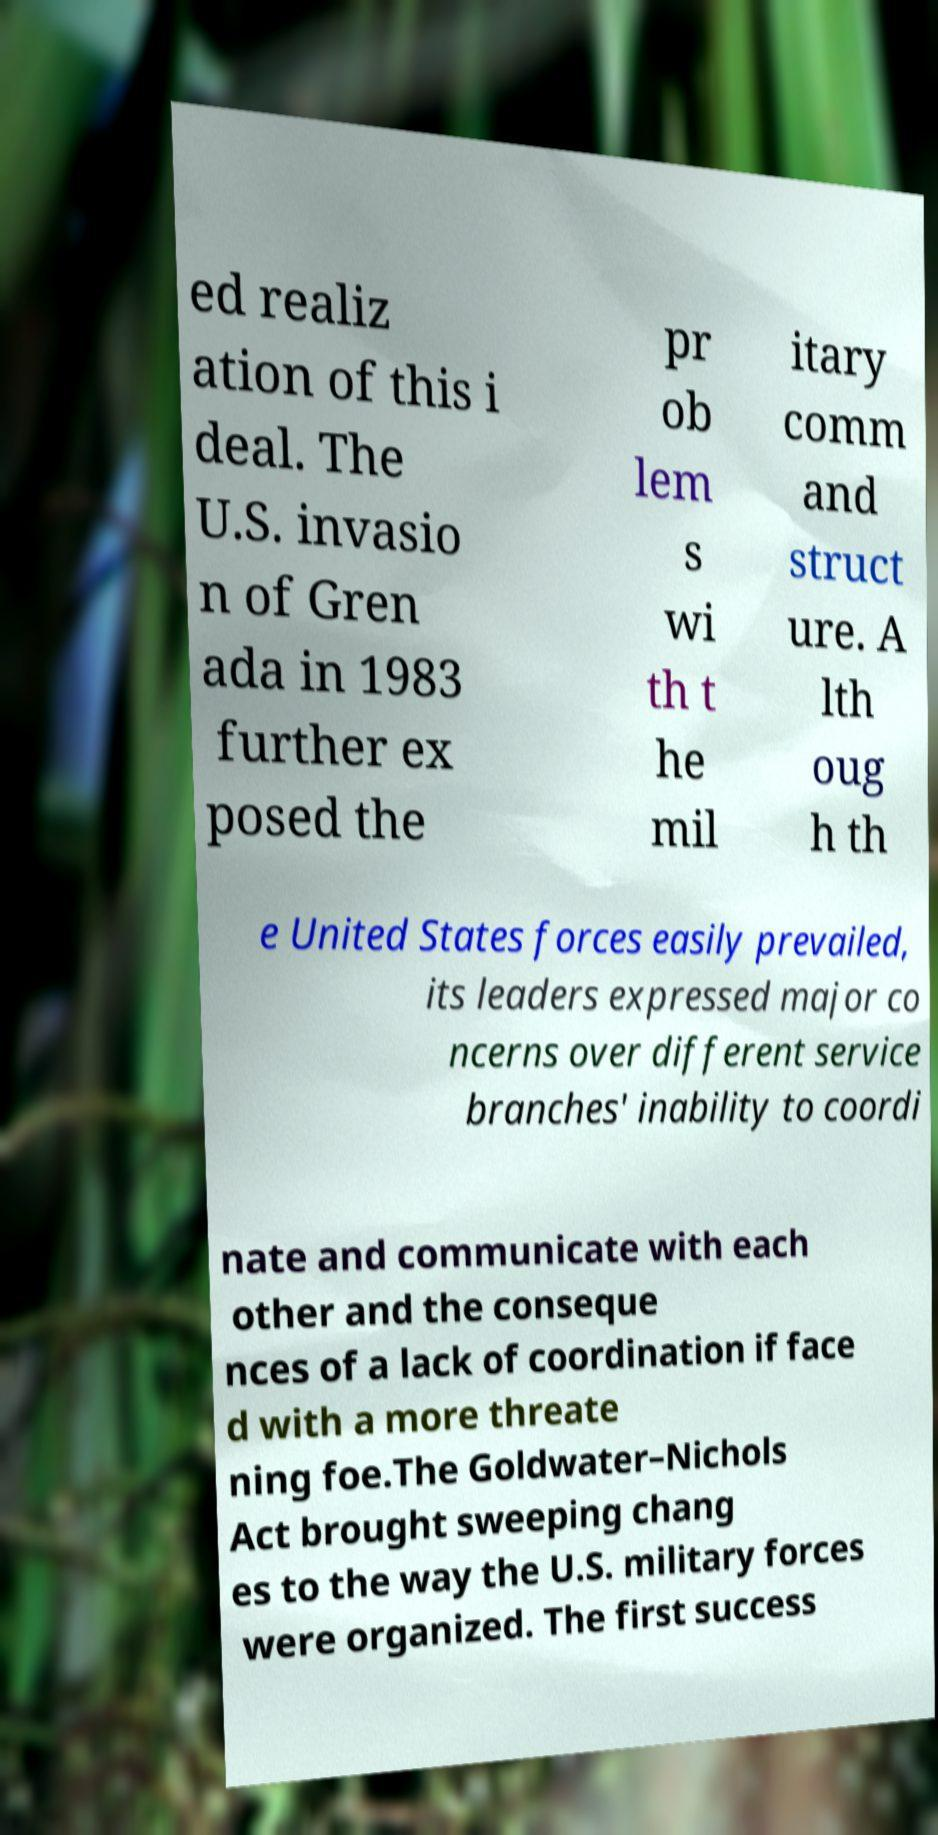For documentation purposes, I need the text within this image transcribed. Could you provide that? ed realiz ation of this i deal. The U.S. invasio n of Gren ada in 1983 further ex posed the pr ob lem s wi th t he mil itary comm and struct ure. A lth oug h th e United States forces easily prevailed, its leaders expressed major co ncerns over different service branches' inability to coordi nate and communicate with each other and the conseque nces of a lack of coordination if face d with a more threate ning foe.The Goldwater–Nichols Act brought sweeping chang es to the way the U.S. military forces were organized. The first success 